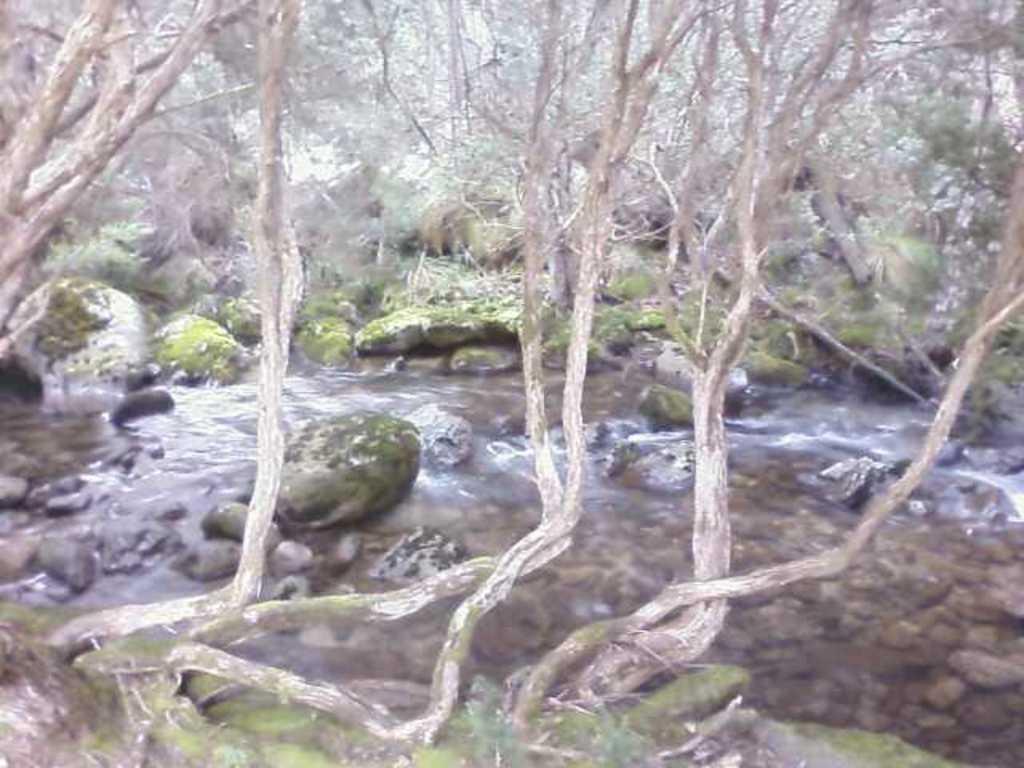How would you summarize this image in a sentence or two? In the picture we can see a water flow in the forest area near the stones and rocks. 